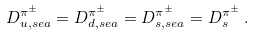<formula> <loc_0><loc_0><loc_500><loc_500>D ^ { \pi ^ { \pm } } _ { u , s e a } = D ^ { \pi ^ { \pm } } _ { d , s e a } = D ^ { \pi ^ { \pm } } _ { s , s e a } = D ^ { \pi ^ { \pm } } _ { s } \, .</formula> 